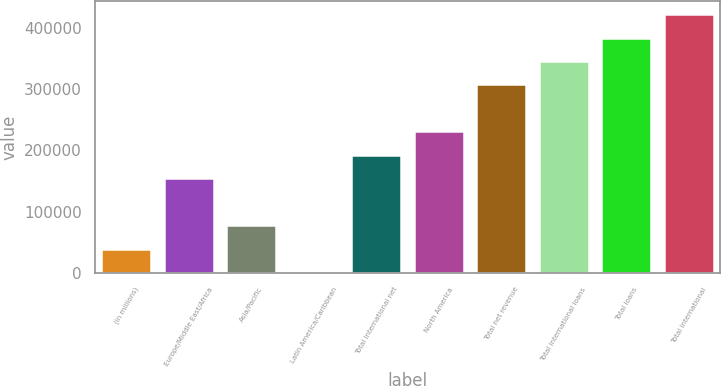Convert chart to OTSL. <chart><loc_0><loc_0><loc_500><loc_500><bar_chart><fcel>(in millions)<fcel>Europe/Middle East/Africa<fcel>Asia/Pacific<fcel>Latin America/Caribbean<fcel>Total international net<fcel>North America<fcel>Total net revenue<fcel>Total international loans<fcel>Total loans<fcel>Total international<nl><fcel>39572.7<fcel>154271<fcel>77805.4<fcel>1340<fcel>192504<fcel>230736<fcel>307202<fcel>345434<fcel>383667<fcel>421900<nl></chart> 